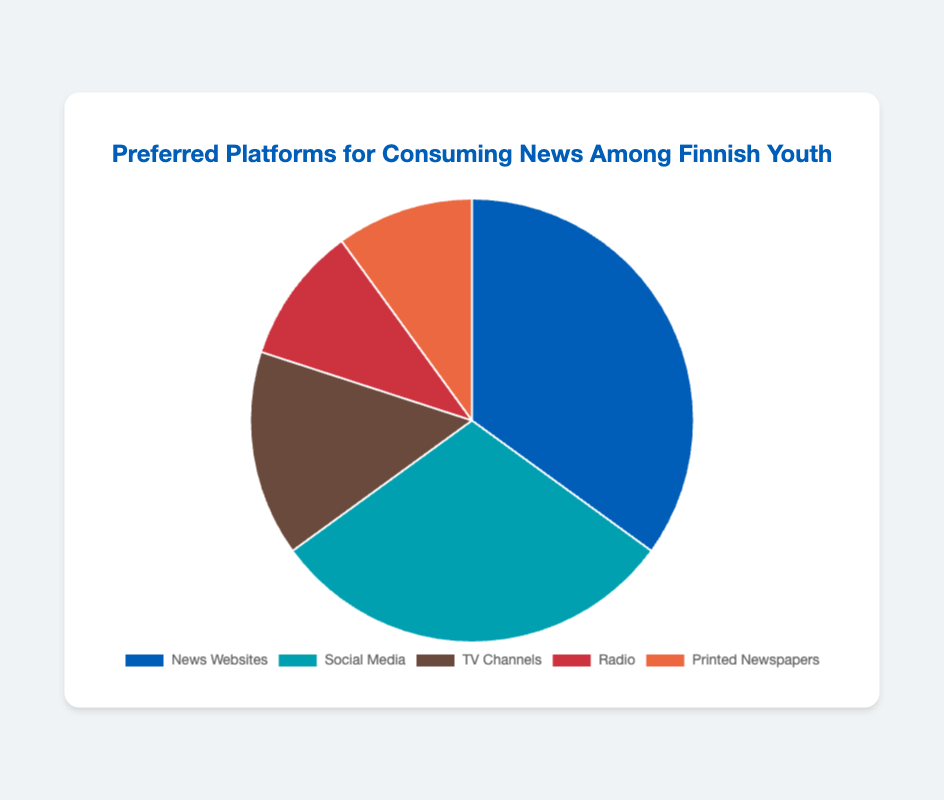Which platform has the highest percentage of preferred use for consuming news among Finnish youth? The platform with the highest percentage is the one with the largest slice of the pie chart. News Websites have the largest slice at 35%.
Answer: News Websites Which platform has the lowest percentage of preferred use for consuming news among Finnish youth? The platforms with the smallest slices are Radio and Printed Newspapers, each with 10%.
Answer: Radio and Printed Newspapers How many percentage points more popular are News Websites compared to Social Media? News Websites are at 35%, and Social Media is at 30%. The difference is 35% - 30% = 5%.
Answer: 5% What is the combined percentage of youth preferring TV Channels and Radio for news consumption? TV Channels have 15%, and Radio has 10%. Summing them up, 15% + 10% = 25%.
Answer: 25% Are there more Finnish youth preferring Social Media over Printed Newspapers for consuming news? Yes, Social Media is preferred by 30% of Finnish youth, while Printed Newspapers are preferred by 10%.
Answer: Yes What proportion of the youth prefers digital platforms (News Websites and Social Media) for consuming news? News Websites account for 35%, and Social Media is another 30%. So, 35% + 30% = 65% prefer digital platforms.
Answer: 65% What is the percentage difference between the least and most preferred platforms for consuming news? The most preferred platform is News Websites at 35%, and the least preferred are Radio and Printed Newspapers at 10%. The difference is 35% - 10% = 25%.
Answer: 25% If you sum the percentages for the least two popular platforms, how does this compare to the percentage for News Websites? The least popular platforms are Radio and Printed Newspapers, each with 10%. The sum is 10% + 10% = 20%. News Websites have 35%, which is 15% higher than this sum.
Answer: News Websites is 15% higher Which platform is preferred by an equal percentage of Finnish youth, and what is that percentage? Radio and Printed Newspapers are both preferred by 10% of Finnish youth.
Answer: 10% 